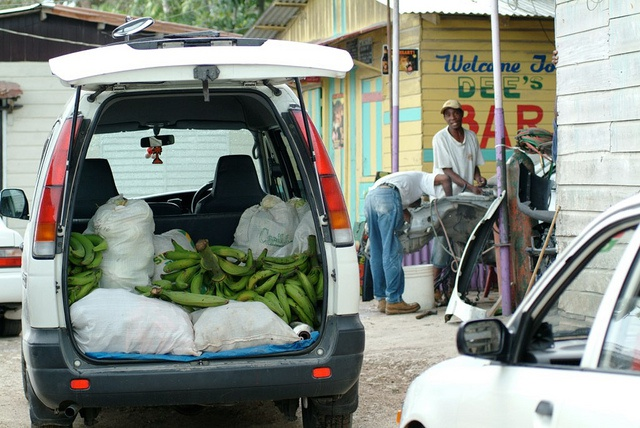Describe the objects in this image and their specific colors. I can see truck in darkgray, black, lightgray, and gray tones, car in darkgray, white, black, and gray tones, truck in darkgray, white, black, and gray tones, banana in darkgray, black, darkgreen, and olive tones, and people in darkgray, blue, lightgray, and gray tones in this image. 